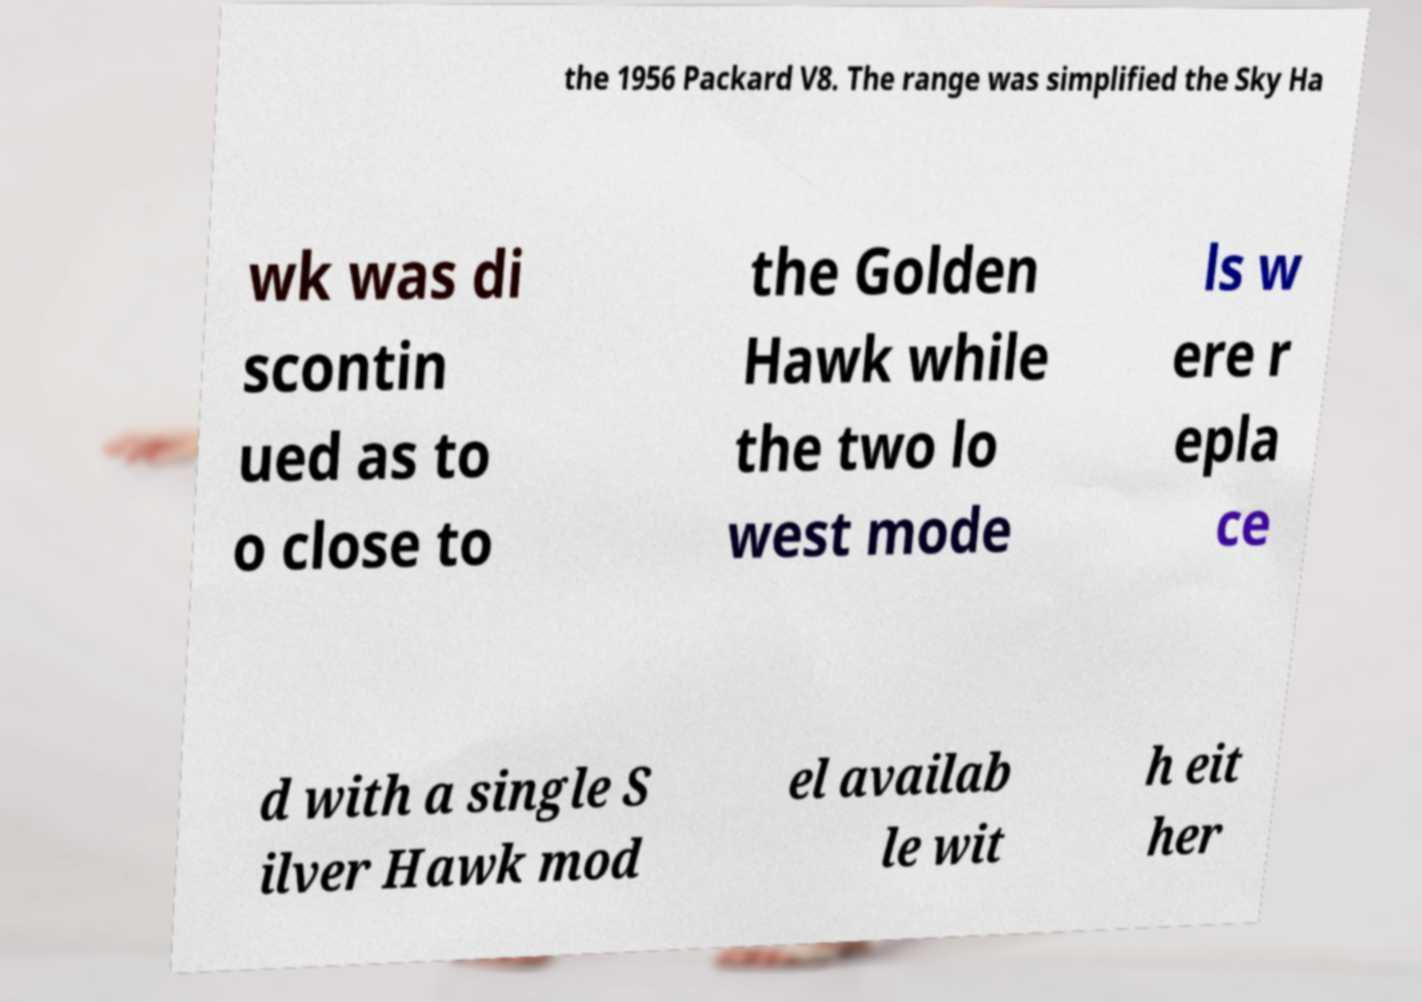Please read and relay the text visible in this image. What does it say? the 1956 Packard V8. The range was simplified the Sky Ha wk was di scontin ued as to o close to the Golden Hawk while the two lo west mode ls w ere r epla ce d with a single S ilver Hawk mod el availab le wit h eit her 